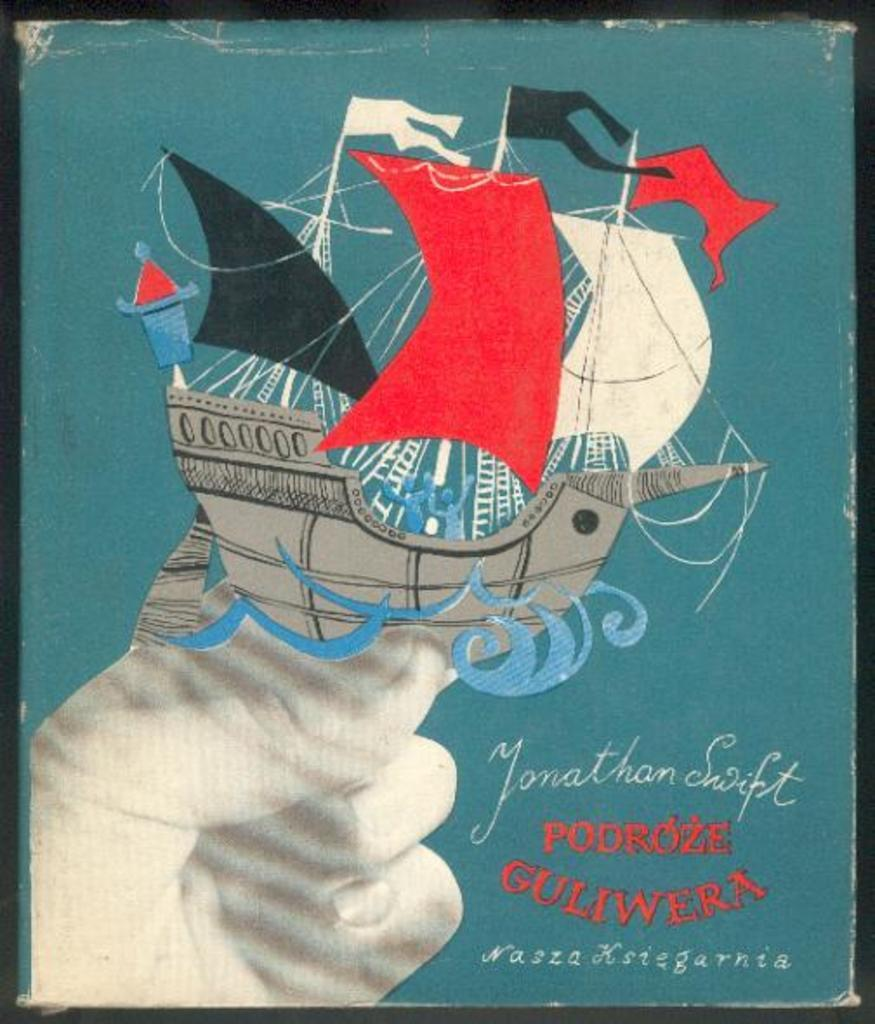What is the main subject of the image? There is a painting in the image. What is depicted in the painting? The painting depicts a hand and a ship. Are there any words or letters on the painting? Yes, there is written text on the painting. How many trees are visible in the painting? There are no trees depicted in the painting; it features a hand and a ship. What type of sock is being worn by the hand in the painting? There is no sock present in the painting; it only depicts a hand and a ship. 